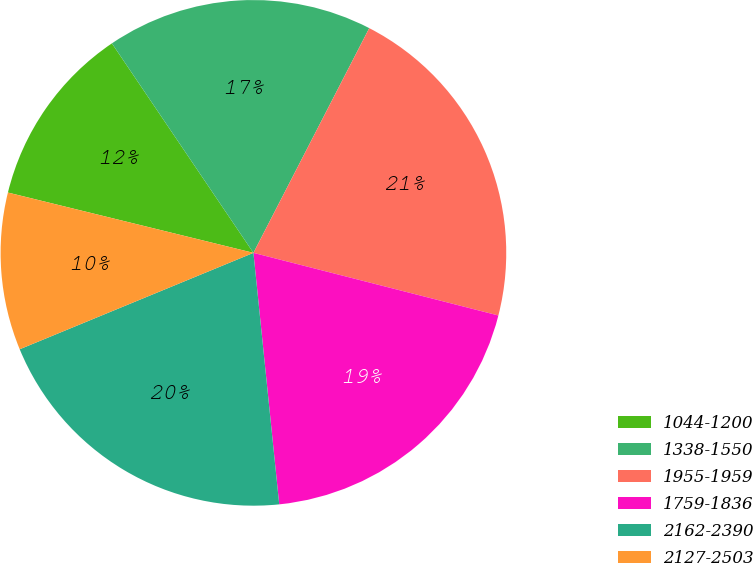Convert chart. <chart><loc_0><loc_0><loc_500><loc_500><pie_chart><fcel>1044-1200<fcel>1338-1550<fcel>1955-1959<fcel>1759-1836<fcel>2162-2390<fcel>2127-2503<nl><fcel>11.71%<fcel>17.03%<fcel>21.41%<fcel>19.39%<fcel>20.4%<fcel>10.06%<nl></chart> 